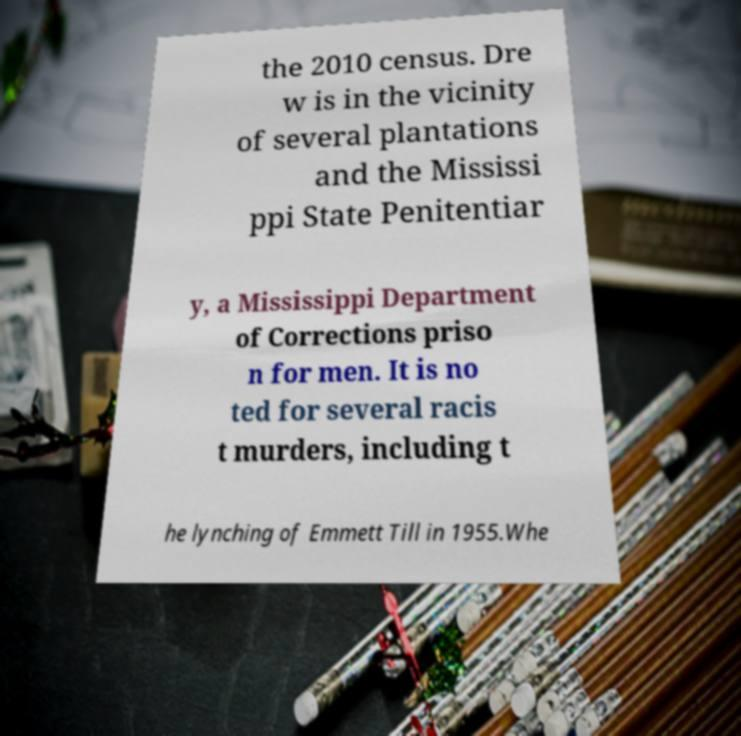Can you read and provide the text displayed in the image?This photo seems to have some interesting text. Can you extract and type it out for me? the 2010 census. Dre w is in the vicinity of several plantations and the Mississi ppi State Penitentiar y, a Mississippi Department of Corrections priso n for men. It is no ted for several racis t murders, including t he lynching of Emmett Till in 1955.Whe 